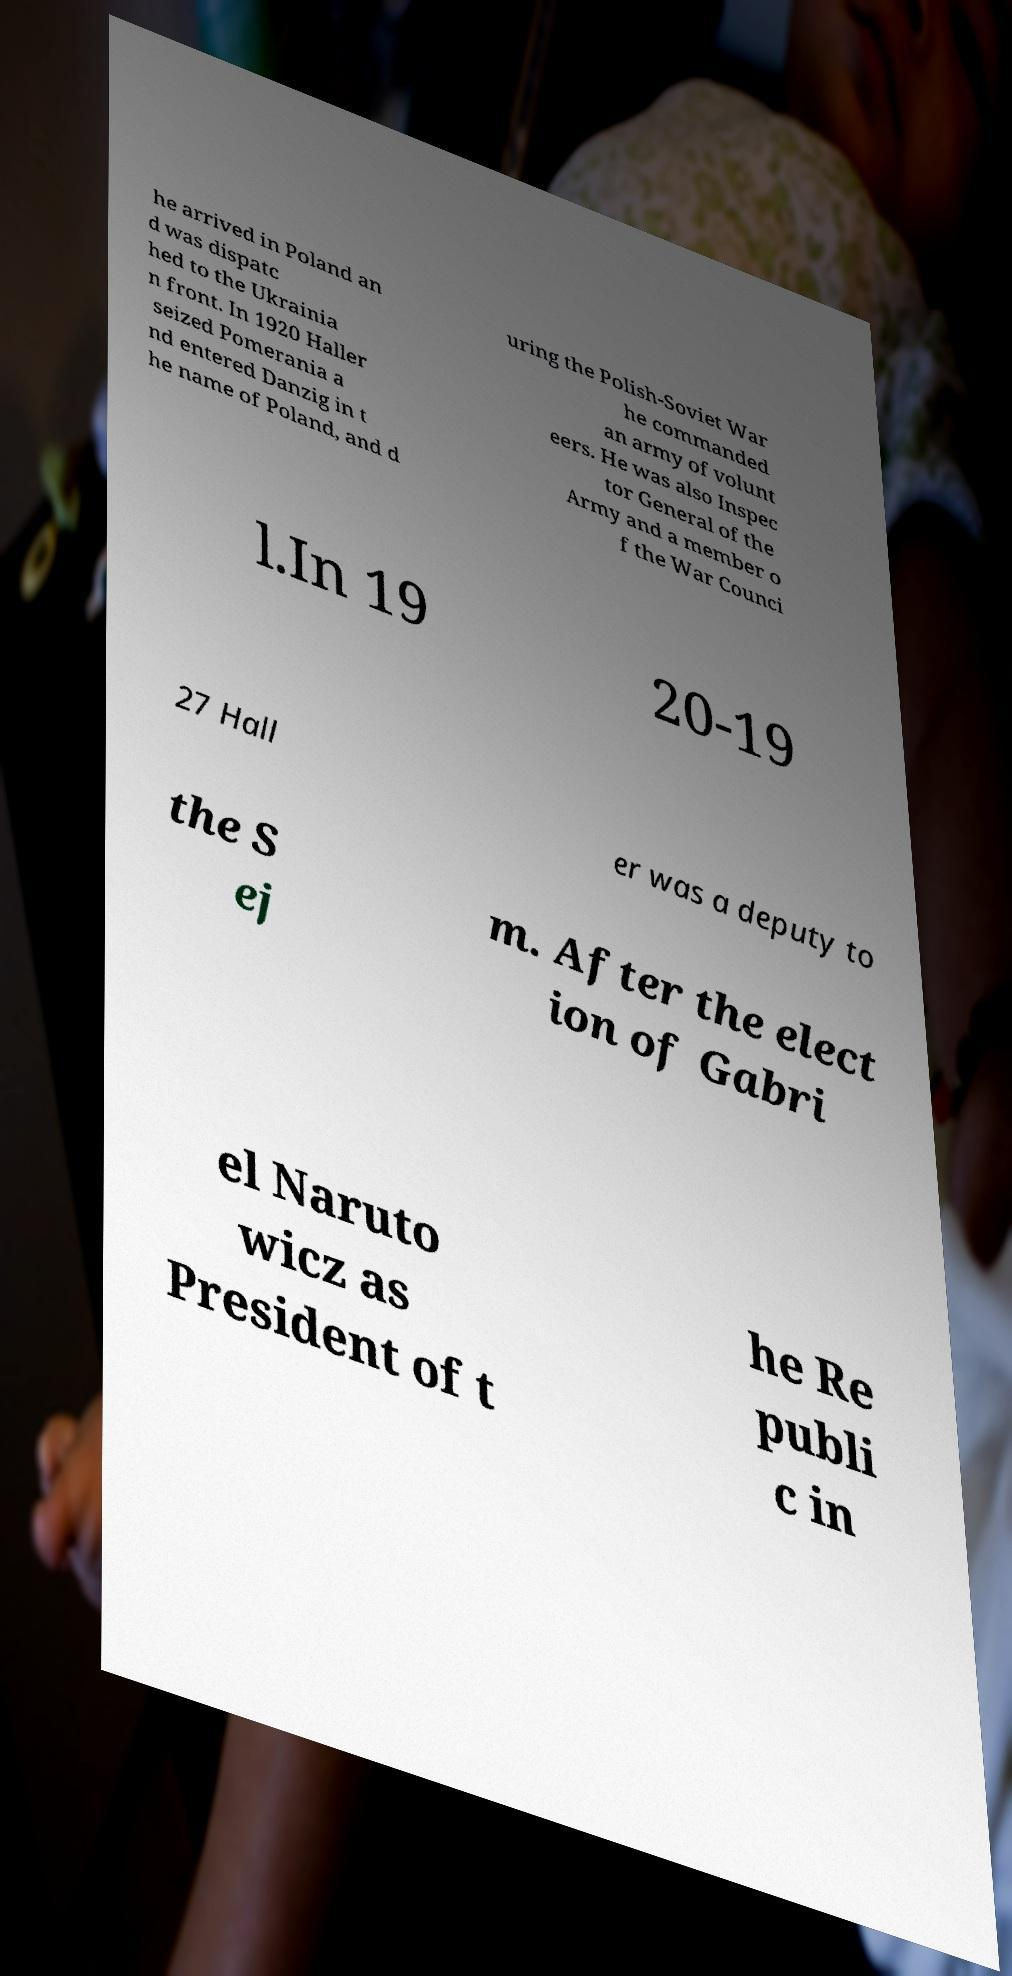Can you accurately transcribe the text from the provided image for me? he arrived in Poland an d was dispatc hed to the Ukrainia n front. In 1920 Haller seized Pomerania a nd entered Danzig in t he name of Poland, and d uring the Polish-Soviet War he commanded an army of volunt eers. He was also Inspec tor General of the Army and a member o f the War Counci l.In 19 20-19 27 Hall er was a deputy to the S ej m. After the elect ion of Gabri el Naruto wicz as President of t he Re publi c in 